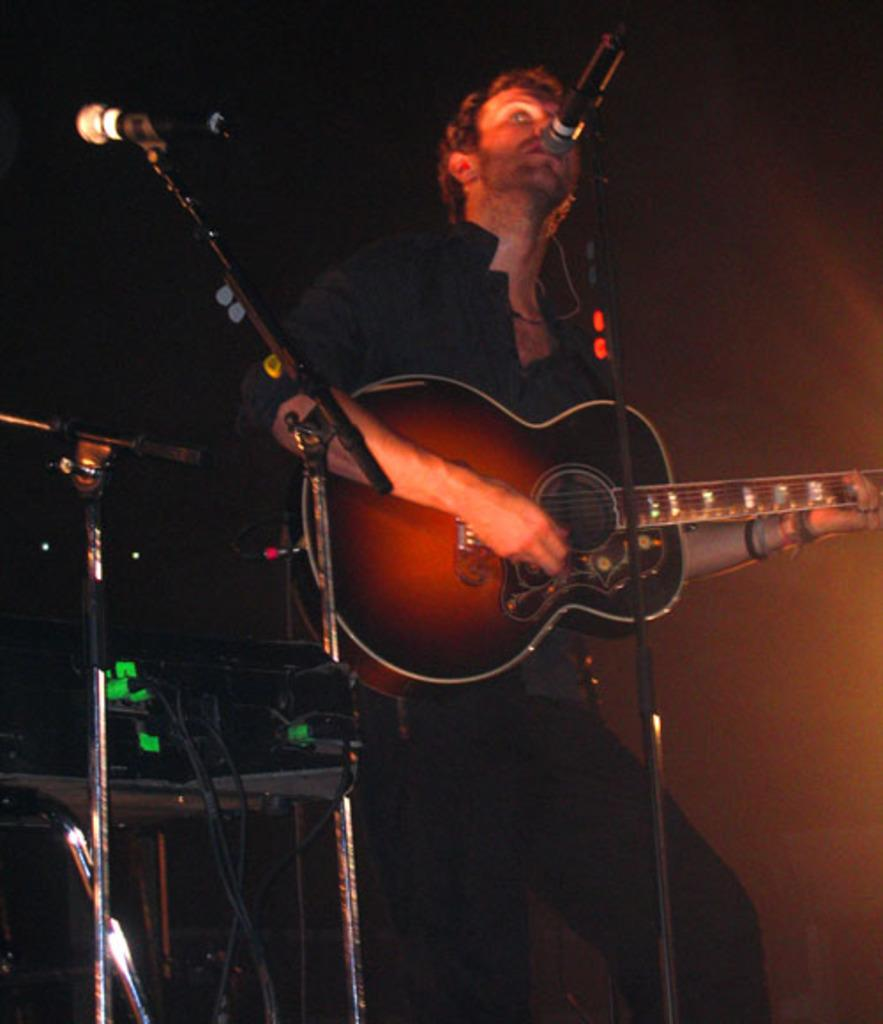What is the main subject of the image? There is a person in the image. What is the person doing in the image? The person is standing and holding a guitar in his hands. What object is in front of the person? There is a microphone in front of the person. What type of slope can be seen in the image? There is no slope present in the image. Can you tell me how many kettles are visible in the image? There are no kettles present in the image. 